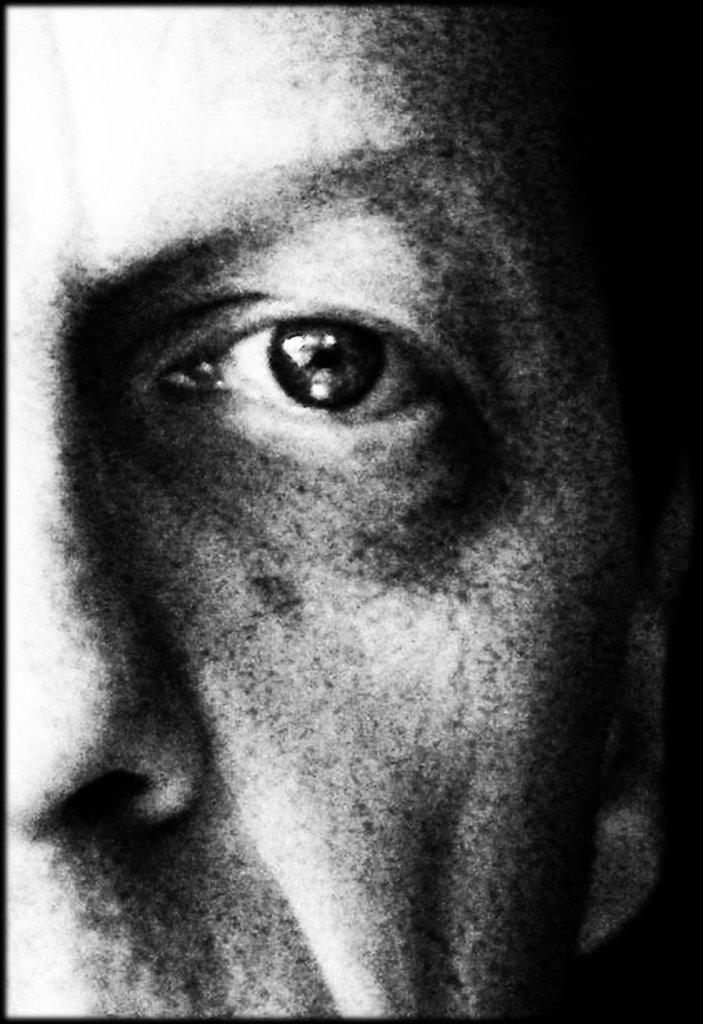What is the main subject of the image? The main subject of the image is a person's face. What is the color scheme of the image? The image is black and white. Can you tell me how many steps the person is taking in the image? There is no indication of the person taking steps in the image, as it only shows their face. Is the person swimming in the image? There is no indication of the person swimming in the image, as it only shows their face. 